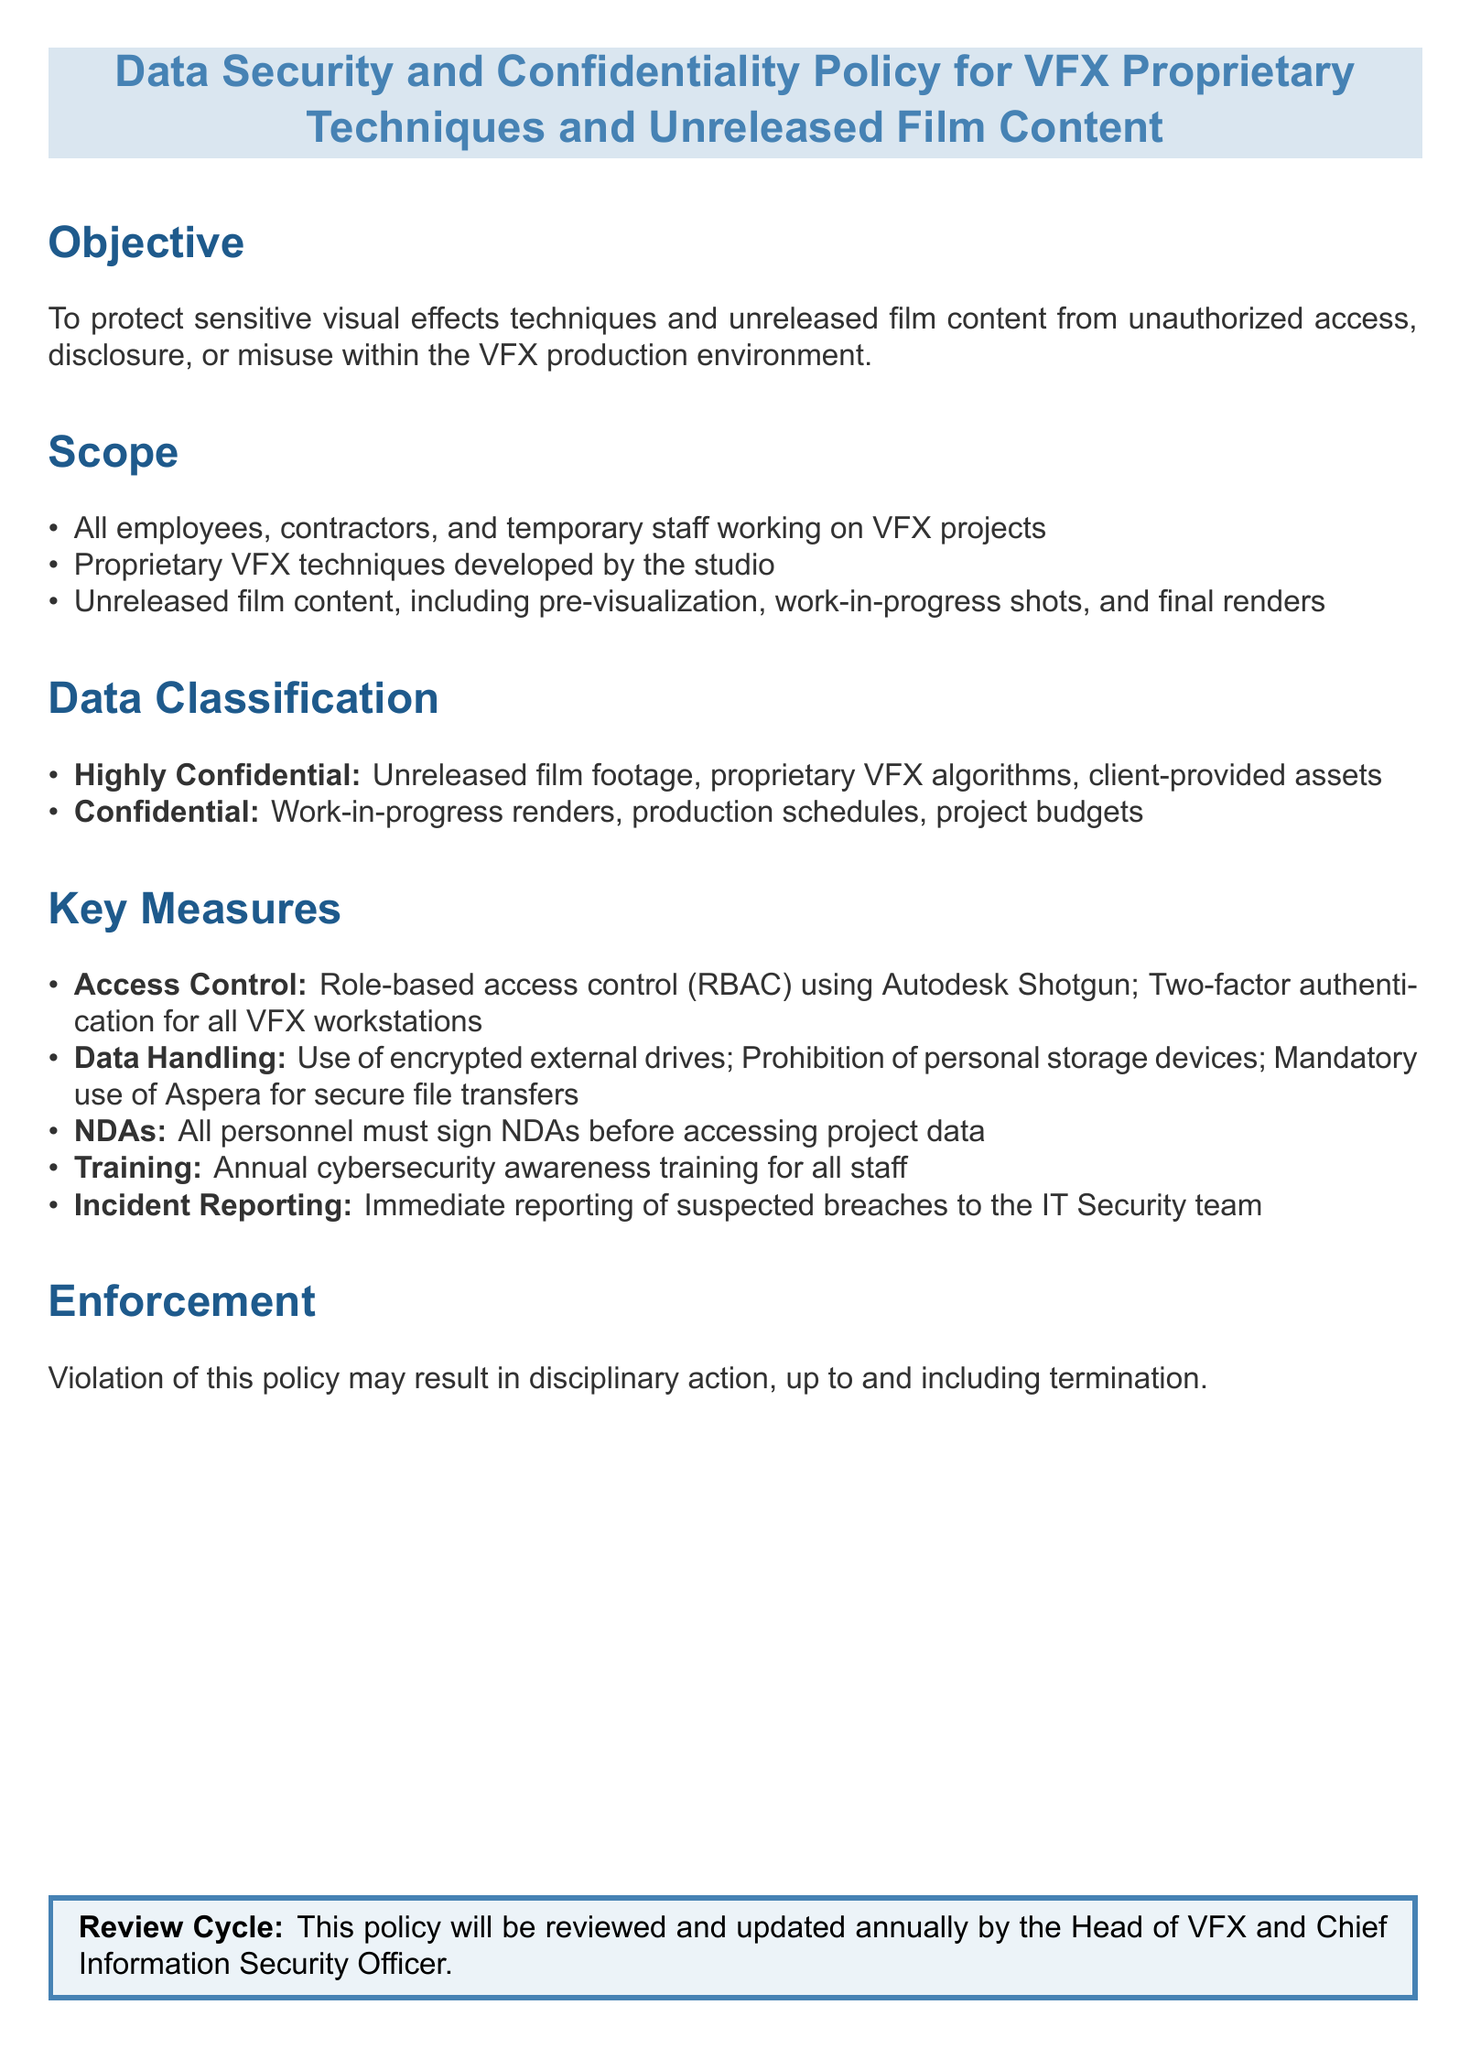What is the objective of the policy? The objective is stated to protect sensitive visual effects techniques and unreleased film content from unauthorized access, disclosure, or misuse.
Answer: Protect sensitive visual effects techniques and unreleased film content Who must sign NDAs? The policy specifies that all personnel must sign NDAs before accessing project data.
Answer: All personnel What type of access control is used? The document mentions role-based access control (RBAC) as the method of access control implemented.
Answer: Role-based access control (RBAC) What is classified as "Highly Confidential"? The document lists unreleased film footage, proprietary VFX algorithms, and client-provided assets as highly confidential.
Answer: Unreleased film footage, proprietary VFX algorithms, client-provided assets How often is cybersecurity awareness training conducted? The policy states that training is mandatory on an annual basis for all staff.
Answer: Annual Who reviews the policy? It is stated that the Head of VFX and Chief Information Security Officer will review the policy annually.
Answer: Head of VFX and Chief Information Security Officer What may result from a violation of this policy? The document outlines that violation may lead to disciplinary action, including termination.
Answer: Disciplinary action, up to and including termination What method is mandatory for secure file transfers? The policy requires the use of Aspera for secure file transfers.
Answer: Aspera What is the consequence of not reporting suspected breaches? The policy does not specify a consequence but emphasizes immediate reporting, indicating its importance.
Answer: Immediate reporting is required 